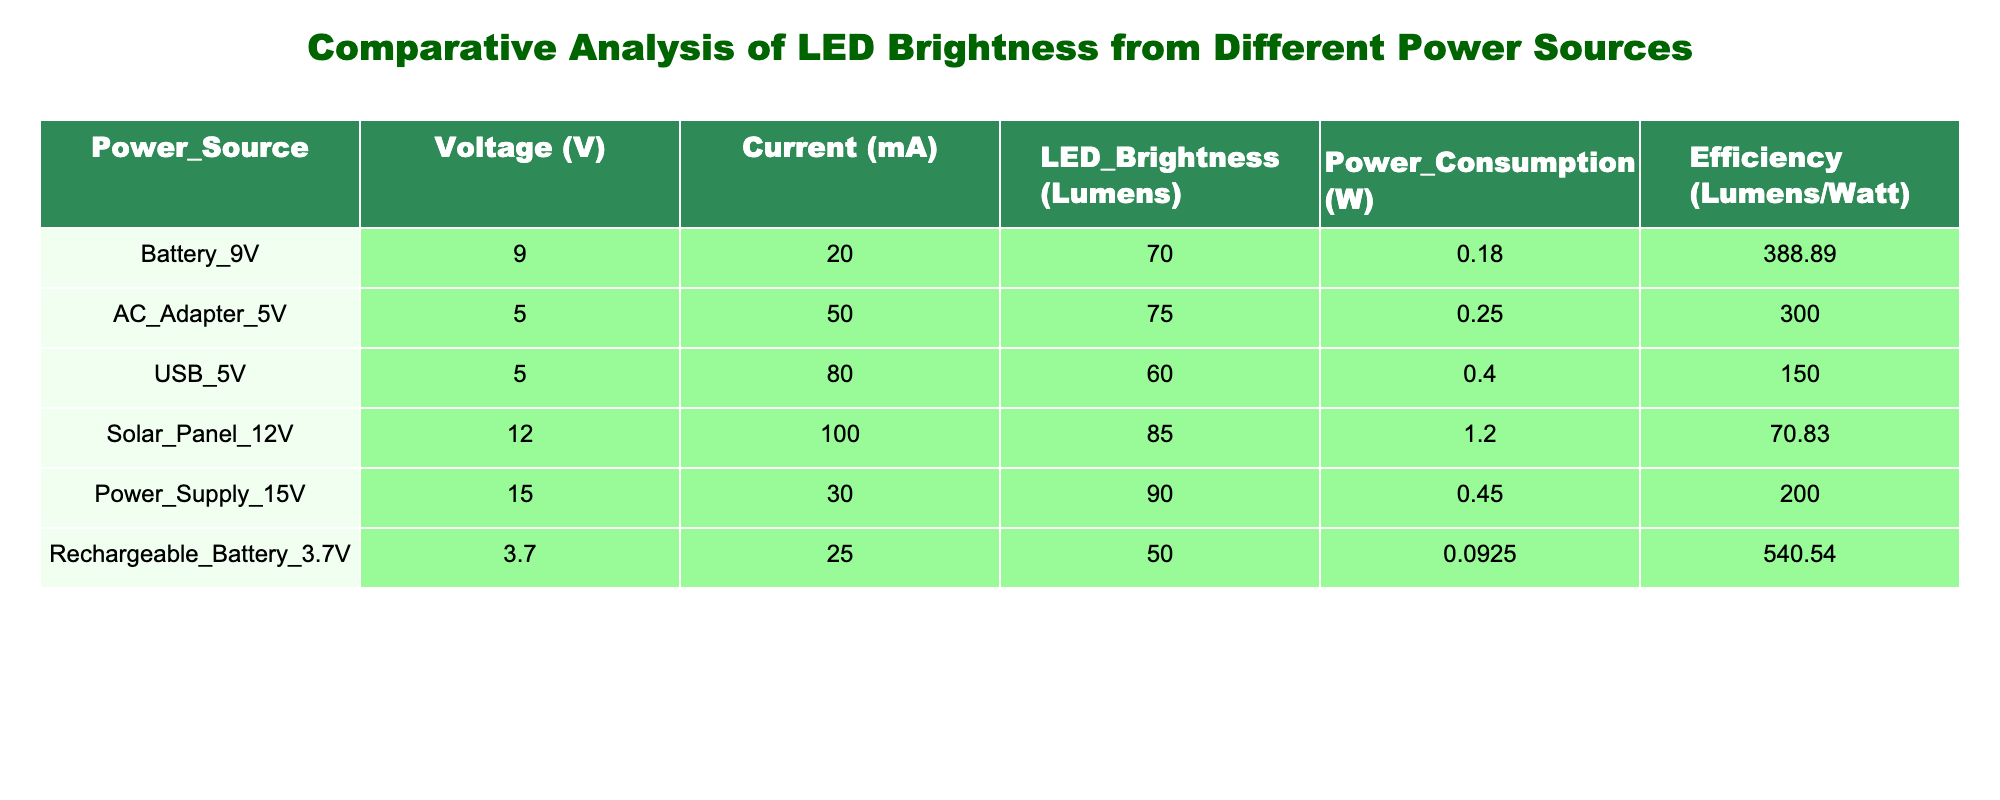What is the LED brightness for the Battery 9V power source? The table lists the values for different power sources, where the brightness for the Battery 9V power source is indicated in the corresponding row. Referring to the row for Battery 9V, the brightness is 70 Lumens.
Answer: 70 Lumens Which power source has the highest efficiency? By looking through the efficiency column, we find the values: Battery 9V - 388.89, AC Adapter 5V - 300.00, USB 5V - 150.00, Solar Panel 12V - 70.83, Power Supply 15V - 200.00, and Rechargeable Battery 3.7V - 540.54. The highest among these is for the Rechargeable Battery 3.7V.
Answer: Rechargeable Battery 3.7V What is the total power consumption of the AC Adapter 5V and the USB 5V? In the table, the power consumption values for AC Adapter 5V and USB 5V are 0.25 Watts and 0.40 Watts respectively. Summing these gives: 0.25 + 0.40 = 0.65 Watts.
Answer: 0.65 Watts Is the brightness of the Solar Panel 12V higher than that of the USB 5V? According to the table, the brightness of the Solar Panel 12V is 85 lumens while the brightness of the USB 5V is 60 lumens. Since 85 is greater than 60, the statement is true.
Answer: Yes What is the average LED brightness of all power sources in the table? First, we sum the LED brightness values: 70 (Battery 9V) + 75 (AC Adapter 5V) + 60 (USB 5V) + 85 (Solar Panel 12V) + 90 (Power Supply 15V) + 50 (Rechargeable Battery 3.7V) = 430 Lumens. There are 6 power sources, so we calculate the average: 430 / 6 = 71.67 Lumens.
Answer: 71.67 Lumens Which power source has a voltage below 5V? Looking through the table, the only power source with a voltage below 5V is the Rechargeable Battery 3.7V which has a voltage of 3.7V.
Answer: Yes Calculate the difference in LED brightness between the highest and lowest recorded values. The highest brightness is 90 Lumens (Power Supply 15V) and the lowest is 50 Lumens (Rechargeable Battery 3.7V). Therefore, the difference is: 90 - 50 = 40 Lumens.
Answer: 40 Lumens Does the USB 5V consume more power than the Battery 9V power source? The power consumption for USB 5V is 0.40 Watts, while for Battery 9V it is 0.18 Watts. Since 0.40 is greater than 0.18, the statement is true.
Answer: Yes 